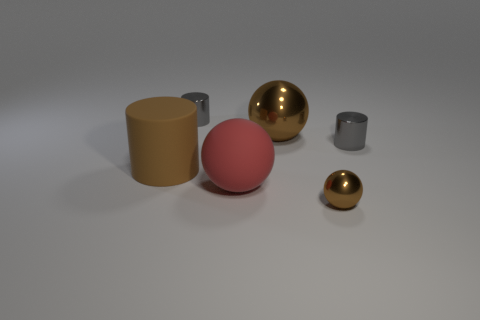Add 1 big matte balls. How many objects exist? 7 Add 3 blue balls. How many blue balls exist? 3 Subtract 0 gray cubes. How many objects are left? 6 Subtract all large gray balls. Subtract all big metallic balls. How many objects are left? 5 Add 1 big brown spheres. How many big brown spheres are left? 2 